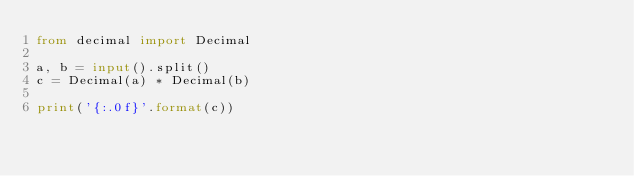Convert code to text. <code><loc_0><loc_0><loc_500><loc_500><_Python_>from decimal import Decimal

a, b = input().split()
c = Decimal(a) * Decimal(b)

print('{:.0f}'.format(c))
</code> 